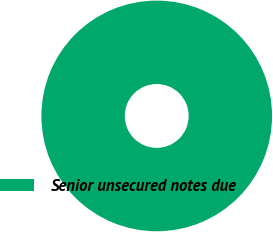<chart> <loc_0><loc_0><loc_500><loc_500><pie_chart><fcel>Senior unsecured notes due<nl><fcel>100.0%<nl></chart> 